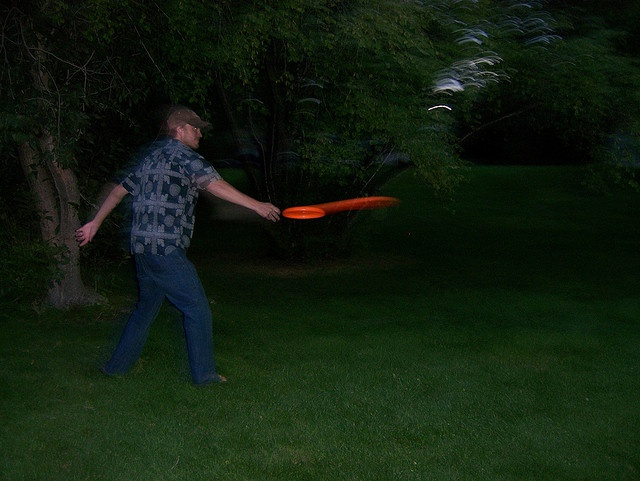Describe the objects in this image and their specific colors. I can see people in black, gray, and brown tones and frisbee in black, brown, red, and maroon tones in this image. 